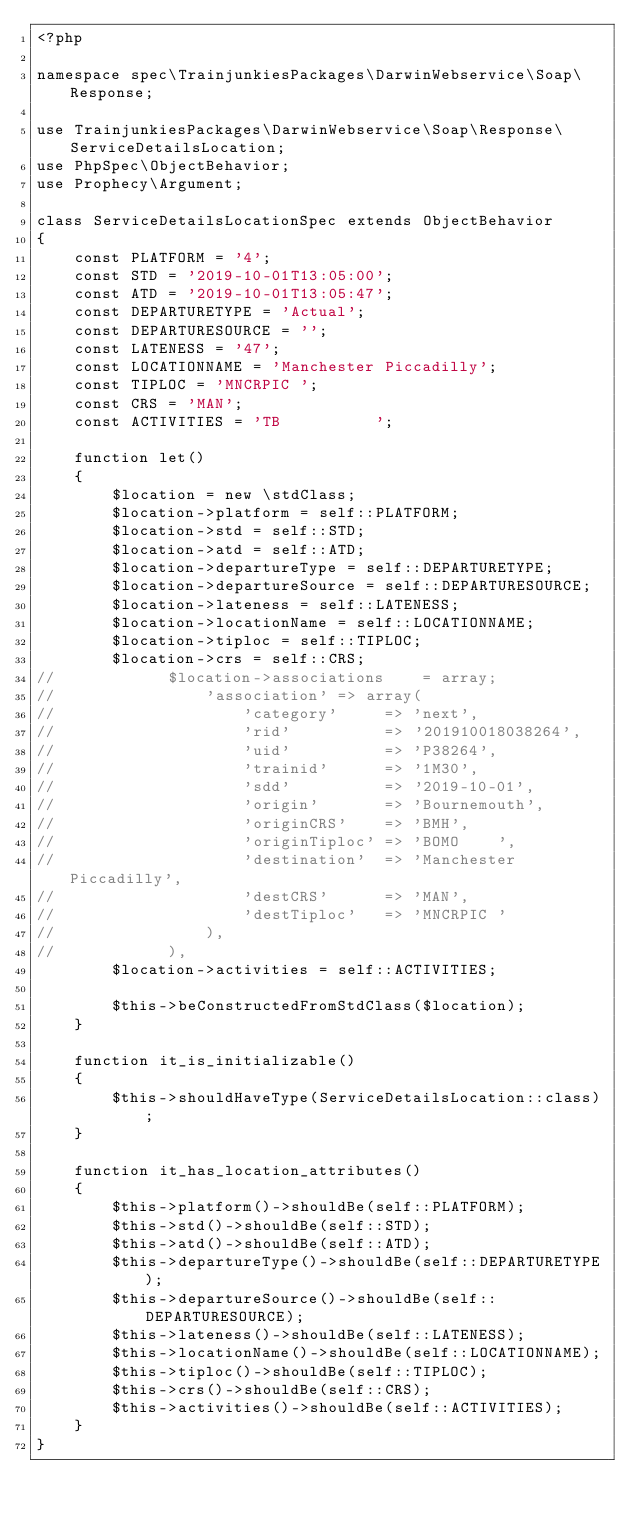Convert code to text. <code><loc_0><loc_0><loc_500><loc_500><_PHP_><?php

namespace spec\TrainjunkiesPackages\DarwinWebservice\Soap\Response;

use TrainjunkiesPackages\DarwinWebservice\Soap\Response\ServiceDetailsLocation;
use PhpSpec\ObjectBehavior;
use Prophecy\Argument;

class ServiceDetailsLocationSpec extends ObjectBehavior
{
    const PLATFORM = '4';
    const STD = '2019-10-01T13:05:00';
    const ATD = '2019-10-01T13:05:47';
    const DEPARTURETYPE = 'Actual';
    const DEPARTURESOURCE = '';
    const LATENESS = '47';
    const LOCATIONNAME = 'Manchester Piccadilly';
    const TIPLOC = 'MNCRPIC ';
    const CRS = 'MAN';
    const ACTIVITIES = 'TB          ';

    function let()
    {
        $location = new \stdClass;
        $location->platform = self::PLATFORM;
        $location->std = self::STD;
        $location->atd = self::ATD;
        $location->departureType = self::DEPARTURETYPE;
        $location->departureSource = self::DEPARTURESOURCE;
        $location->lateness = self::LATENESS;
        $location->locationName = self::LOCATIONNAME;
        $location->tiploc = self::TIPLOC;
        $location->crs = self::CRS;
//            $location->associations    = array;
//                'association' => array(
//                    'category'     => 'next',
//                    'rid'          => '201910018038264',
//                    'uid'          => 'P38264',
//                    'trainid'      => '1M30',
//                    'sdd'          => '2019-10-01',
//                    'origin'       => 'Bournemouth',
//                    'originCRS'    => 'BMH',
//                    'originTiploc' => 'BOMO    ',
//                    'destination'  => 'Manchester Piccadilly',
//                    'destCRS'      => 'MAN',
//                    'destTiploc'   => 'MNCRPIC '
//                ),
//            ),
        $location->activities = self::ACTIVITIES;

        $this->beConstructedFromStdClass($location);
    }

    function it_is_initializable()
    {
        $this->shouldHaveType(ServiceDetailsLocation::class);
    }

    function it_has_location_attributes()
    {
        $this->platform()->shouldBe(self::PLATFORM);
        $this->std()->shouldBe(self::STD);
        $this->atd()->shouldBe(self::ATD);
        $this->departureType()->shouldBe(self::DEPARTURETYPE);
        $this->departureSource()->shouldBe(self::DEPARTURESOURCE);
        $this->lateness()->shouldBe(self::LATENESS);
        $this->locationName()->shouldBe(self::LOCATIONNAME);
        $this->tiploc()->shouldBe(self::TIPLOC);
        $this->crs()->shouldBe(self::CRS);
        $this->activities()->shouldBe(self::ACTIVITIES);
    }
}
</code> 